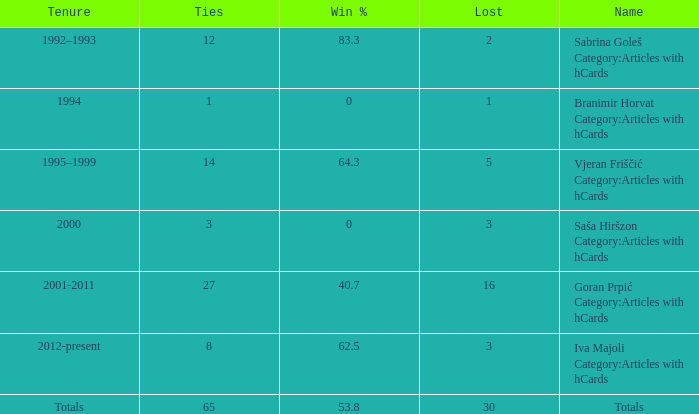Tell me the total number of ties for name of totals and lost more than 30 0.0. 